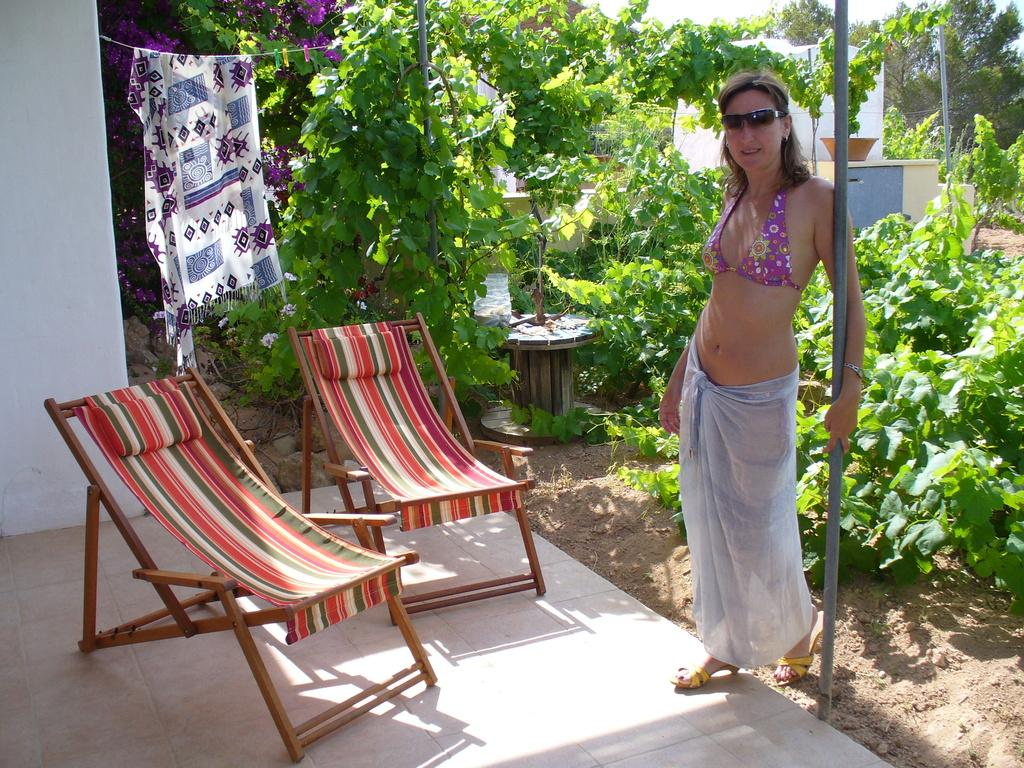Who is present in the image? There is a woman in the image. What is the woman wearing on her face? The woman is wearing goggles. What is the woman standing beside? The woman is standing beside a pole. What can be seen in the background of the image? There are plants and trees in the background of the image. What is in front of the woman? There are chairs in front of the woman. What is hanging from the rope in the image? A scarf is on a rope. Can you see any bears or airplanes in the image? No, there are no bears or airplanes present in the image. Are there any horses visible in the image? No, there are no horses visible in the image. 